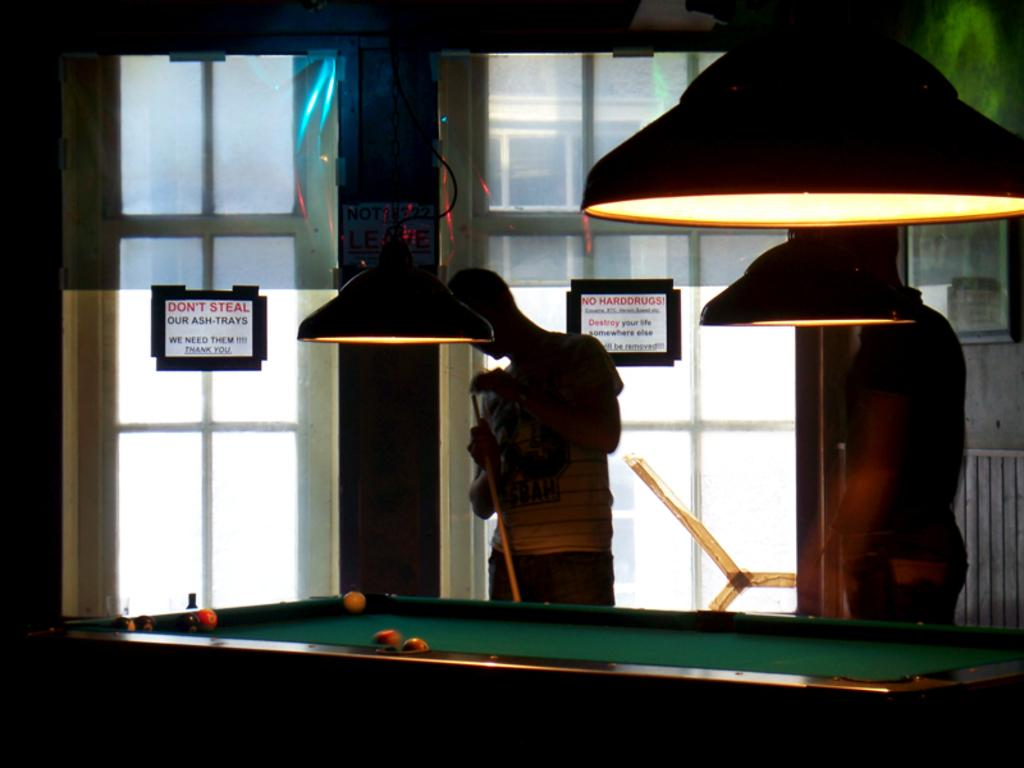How many people are in the image? There are two men in the image. What are the men standing in front of? The men are standing in front of a snooker table. What can be seen on the window in the image? There are two paper notes stuck over the window. Who is the friend standing behind the men in the image? There is no friend standing behind the men in the image. What is the fifth item visible in the image? The provided facts only mention four items: two men, a snooker table, and two paper notes. There is no fifth item visible in the image. 